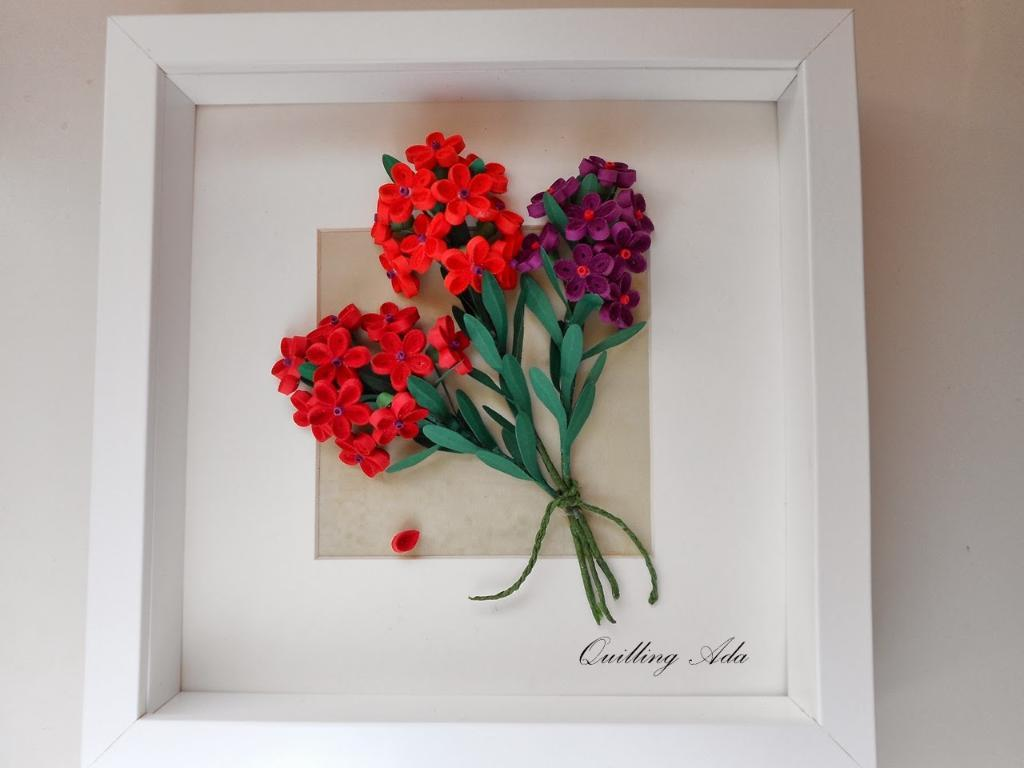What type of flowers are in the image? There is an artificial bouquet in the image. Where is the bouquet located? The bouquet is in a box. What can be seen on the box besides the bouquet? There is text on the box. Where is the text located on the box? The text is at the bottom of the image. What is the color of the background in the image? The background of the image is white. What type of grain is being harvested in the image? There is no grain or harvesting activity present in the image; it features an artificial bouquet in a box. What flavor of juice is being poured from the container in the image? There is no container or juice present in the image. 